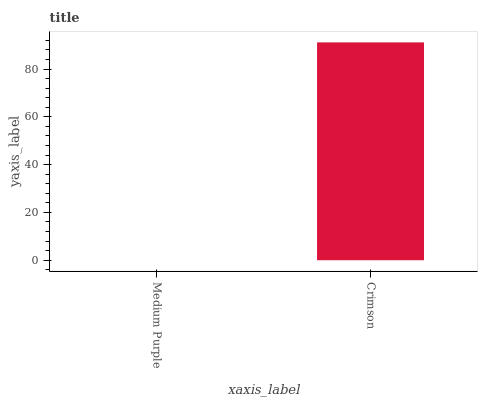Is Medium Purple the minimum?
Answer yes or no. Yes. Is Crimson the maximum?
Answer yes or no. Yes. Is Crimson the minimum?
Answer yes or no. No. Is Crimson greater than Medium Purple?
Answer yes or no. Yes. Is Medium Purple less than Crimson?
Answer yes or no. Yes. Is Medium Purple greater than Crimson?
Answer yes or no. No. Is Crimson less than Medium Purple?
Answer yes or no. No. Is Crimson the high median?
Answer yes or no. Yes. Is Medium Purple the low median?
Answer yes or no. Yes. Is Medium Purple the high median?
Answer yes or no. No. Is Crimson the low median?
Answer yes or no. No. 